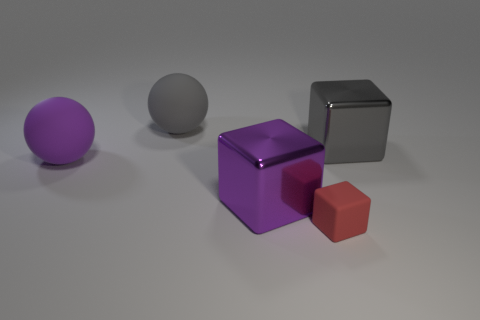Add 1 tiny green matte spheres. How many objects exist? 6 Subtract all blocks. How many objects are left? 2 Subtract 0 red cylinders. How many objects are left? 5 Subtract all gray spheres. Subtract all small cubes. How many objects are left? 3 Add 5 large purple spheres. How many large purple spheres are left? 6 Add 4 matte spheres. How many matte spheres exist? 6 